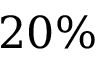<formula> <loc_0><loc_0><loc_500><loc_500>2 0 \%</formula> 